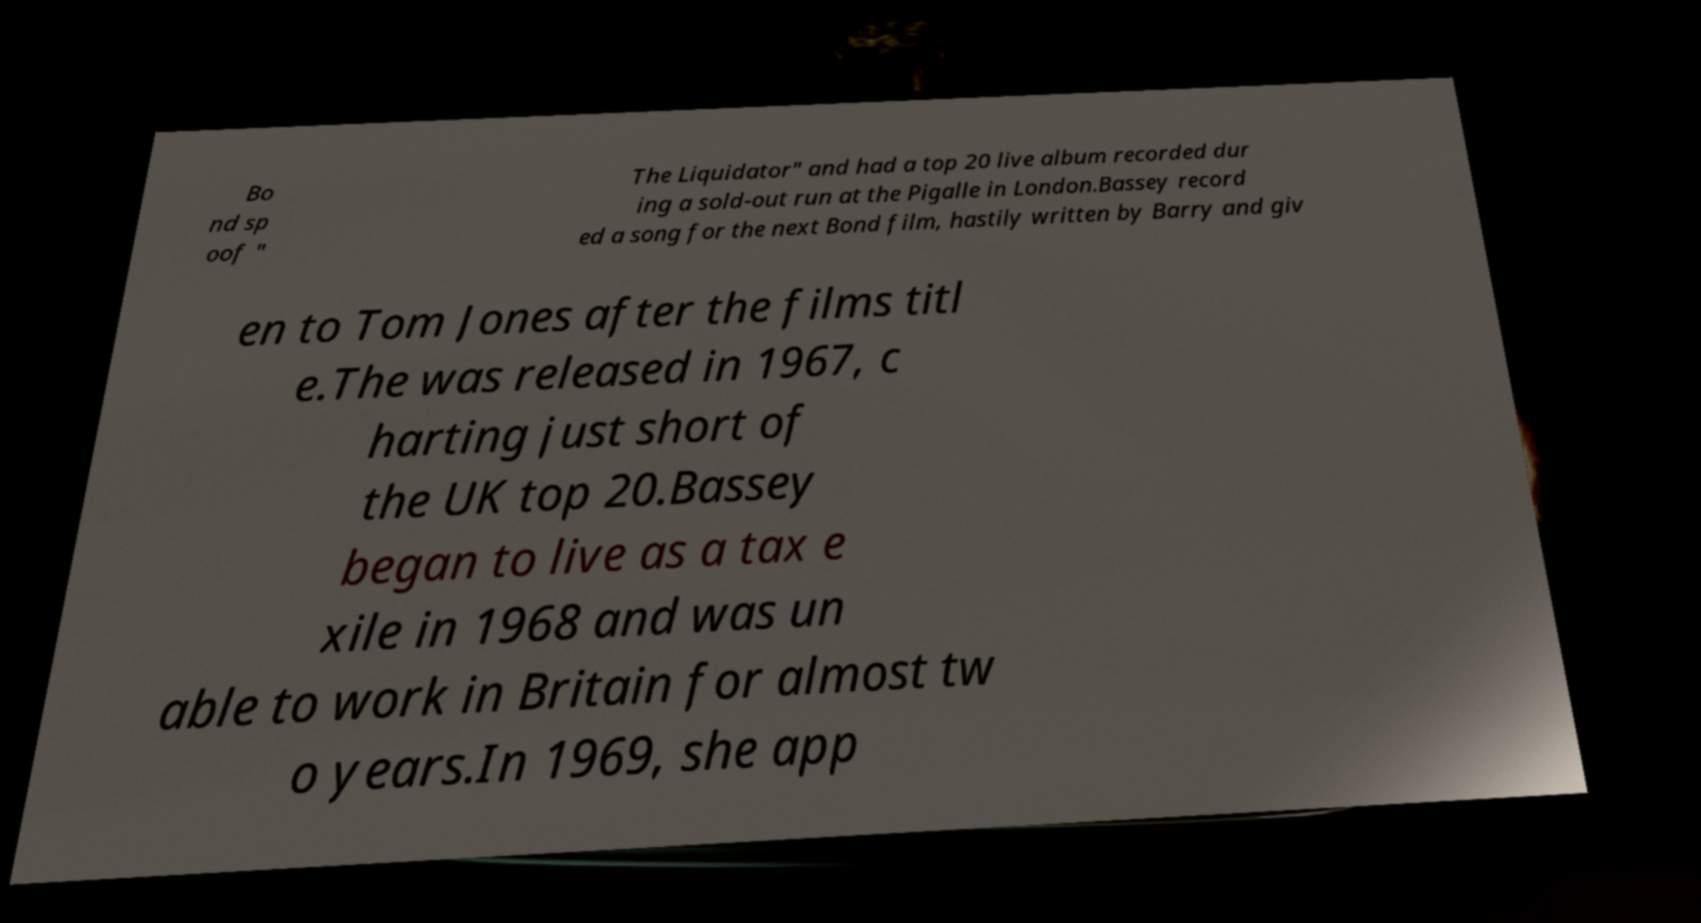Can you read and provide the text displayed in the image?This photo seems to have some interesting text. Can you extract and type it out for me? Bo nd sp oof " The Liquidator" and had a top 20 live album recorded dur ing a sold-out run at the Pigalle in London.Bassey record ed a song for the next Bond film, hastily written by Barry and giv en to Tom Jones after the films titl e.The was released in 1967, c harting just short of the UK top 20.Bassey began to live as a tax e xile in 1968 and was un able to work in Britain for almost tw o years.In 1969, she app 